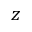Convert formula to latex. <formula><loc_0><loc_0><loc_500><loc_500>z</formula> 